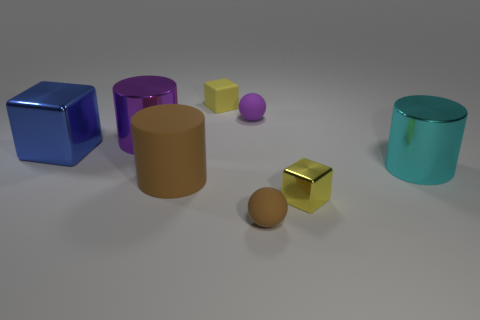Add 2 tiny red cylinders. How many objects exist? 10 Subtract all spheres. How many objects are left? 6 Add 7 metallic cubes. How many metallic cubes are left? 9 Add 1 blue balls. How many blue balls exist? 1 Subtract 1 brown balls. How many objects are left? 7 Subtract all yellow rubber objects. Subtract all brown objects. How many objects are left? 5 